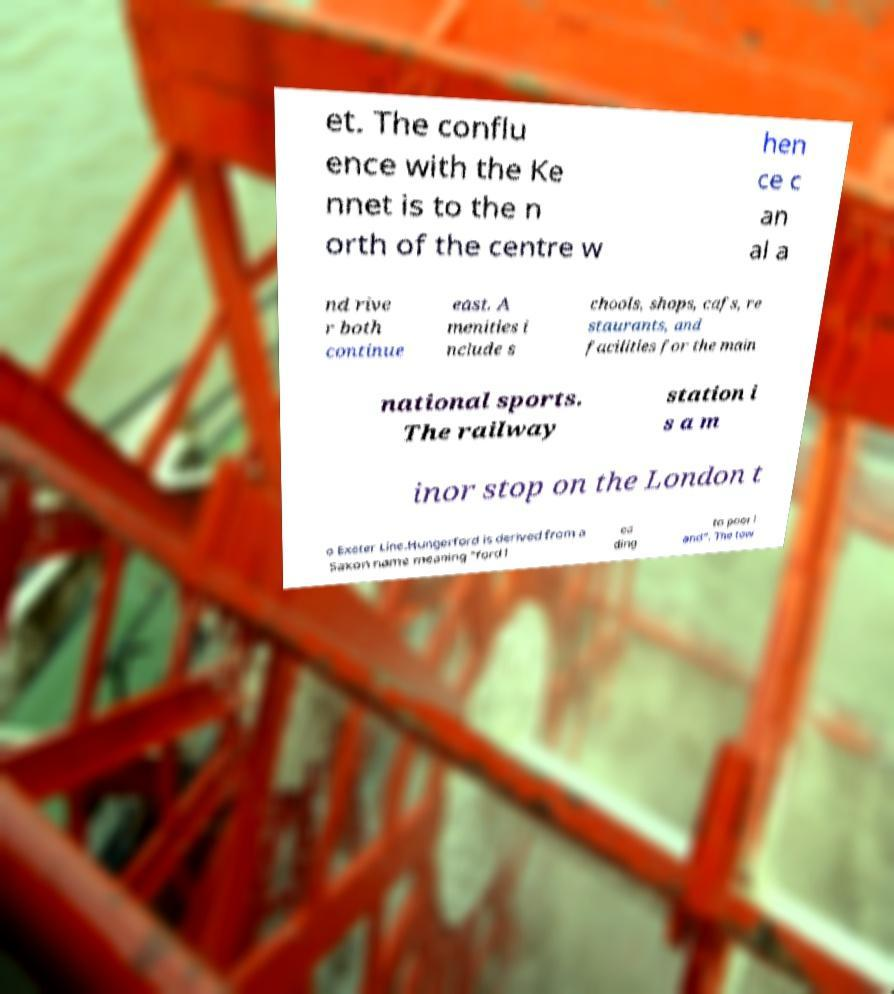Can you read and provide the text displayed in the image?This photo seems to have some interesting text. Can you extract and type it out for me? et. The conflu ence with the Ke nnet is to the n orth of the centre w hen ce c an al a nd rive r both continue east. A menities i nclude s chools, shops, cafs, re staurants, and facilities for the main national sports. The railway station i s a m inor stop on the London t o Exeter Line.Hungerford is derived from a Saxon name meaning "ford l ea ding to poor l and". The tow 